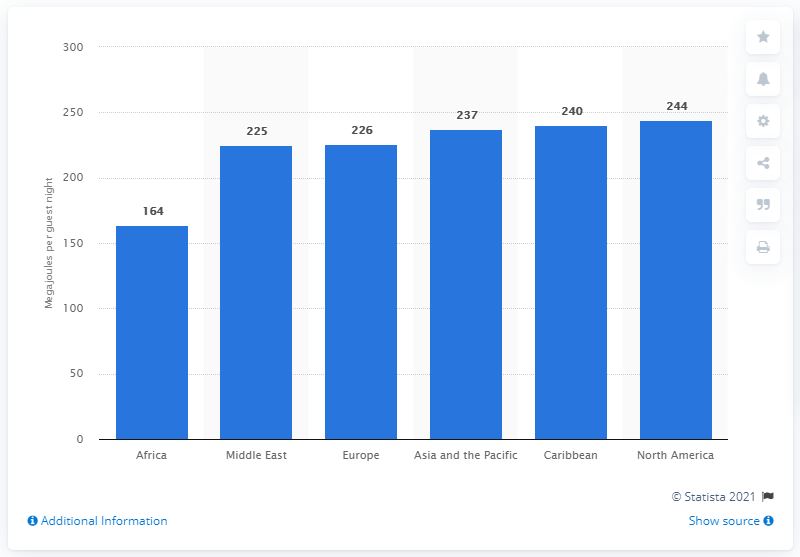Outline some significant characteristics in this image. The average energy consumption per guest in Africa was 164 megajoules. 